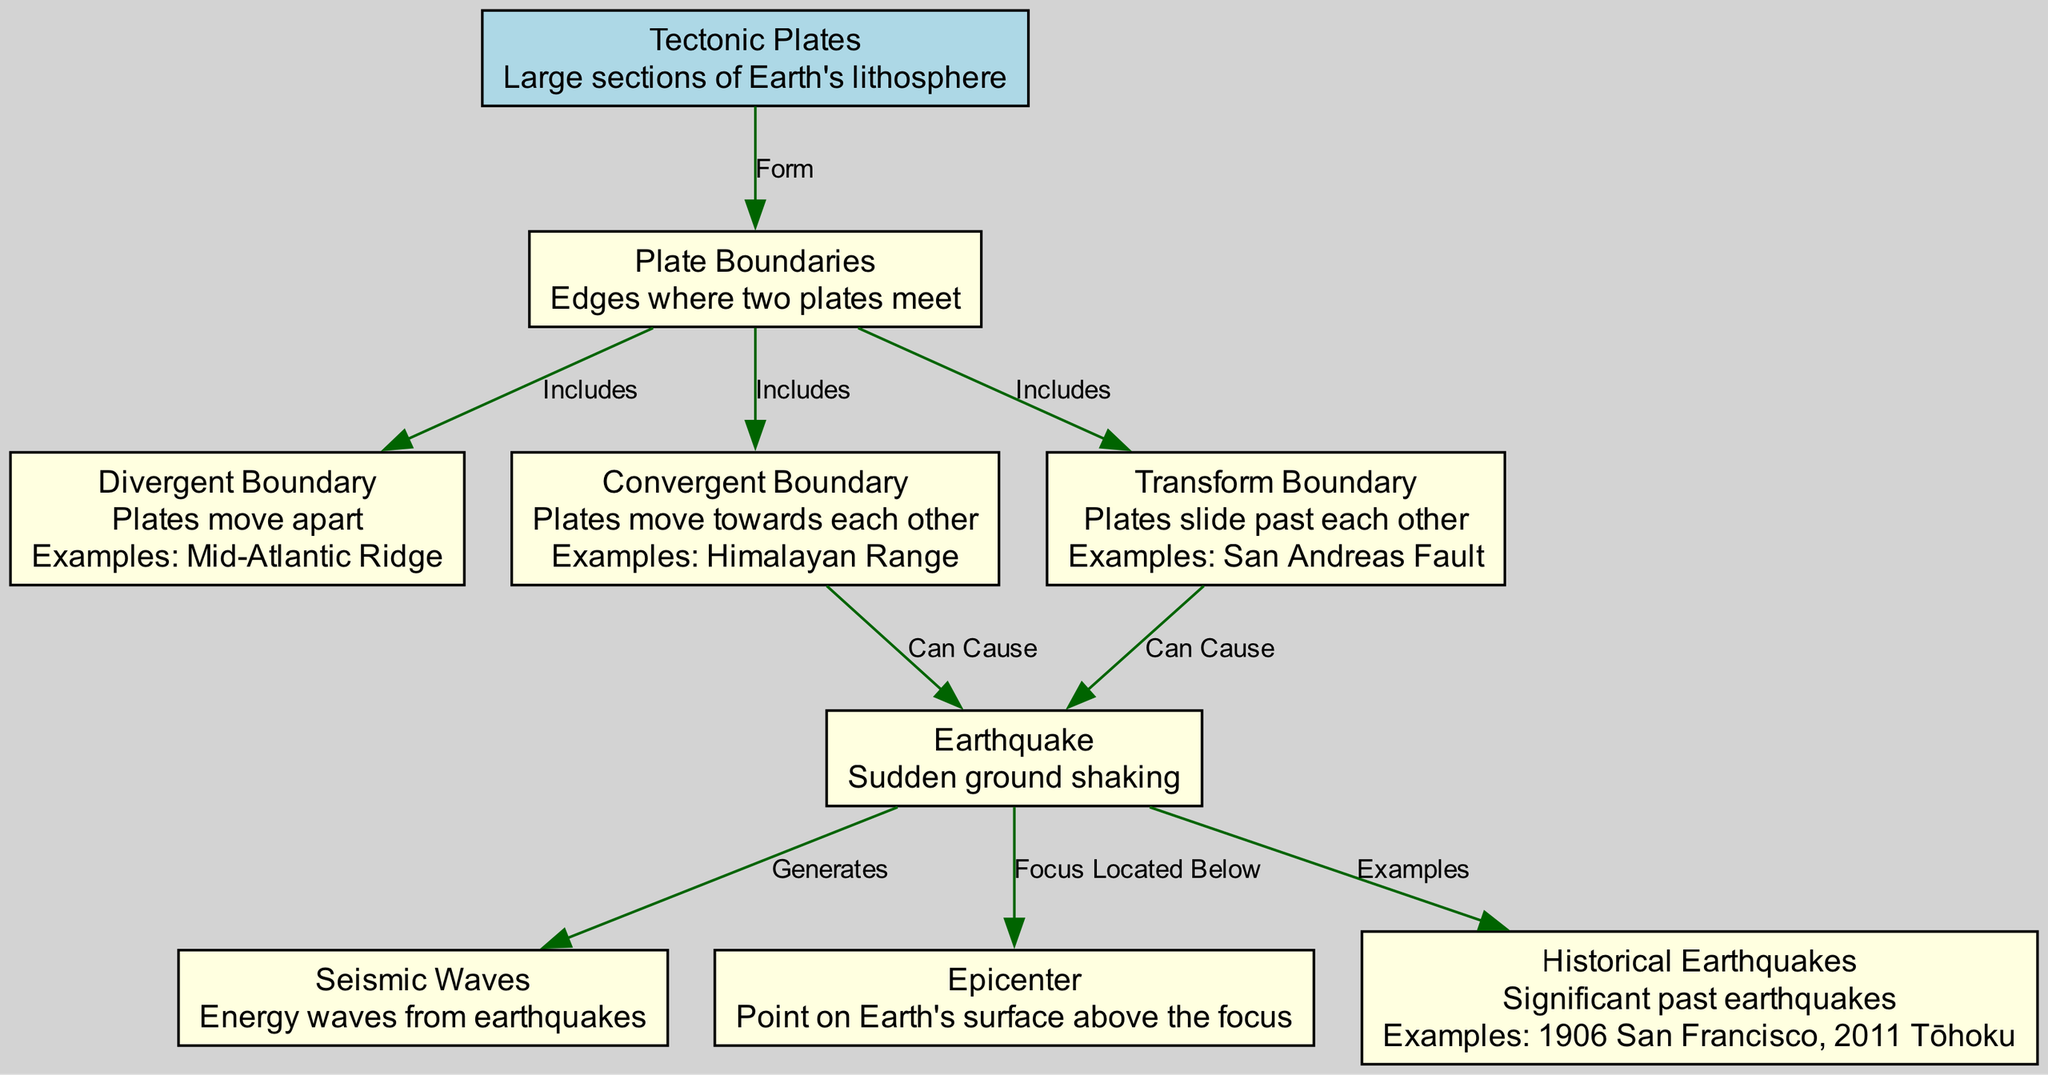What is the point on Earth's surface above the focus of an earthquake called? In the diagram, there is a node labeled "Epicenter," which specifically refers to this point on the surface.
Answer: Epicenter How many types of plate boundaries are represented in the diagram? The diagram includes three types of plate boundaries: Divergent, Convergent, and Transform. Thus, the total count is three.
Answer: Three Which boundary type includes the Mid-Atlantic Ridge? The diagram indicates that the Mid-Atlantic Ridge is an example of a Divergent Boundary, as noted under the description for that node.
Answer: Divergent Boundary What natural event can occur due to Convergent Boundaries? The edge between the Convergent Boundary and the Earthquake node indicates that the movement of plates towards each other can cause earthquakes.
Answer: Earthquake Which historical earthquake is noted in the diagram? The node labeled "Historical Earthquakes" mentions examples, including the "2011 Tōhoku," which represents a significant past event related to earthquakes.
Answer: 2011 Tōhoku What forms the edges where two tectonic plates meet? The relationship between the nodes "Tectonic Plates" and "Plate Boundaries" indicates that these boundaries form at the edges of the tectonic plates.
Answer: Plate Boundaries What generates seismic waves? According to the diagram, seismic waves are generated as a result of earthquakes, reflecting the energy release during such events.
Answer: Earthquake How many examples of historical earthquakes are provided in the diagram? The diagram lists two specific examples under the Historical Earthquakes node—1906 San Francisco and 2011 Tōhoku—indicating a total of two examples.
Answer: Two 